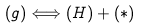Convert formula to latex. <formula><loc_0><loc_0><loc_500><loc_500>\left ( g \right ) \Longleftrightarrow \left ( H \right ) + \left ( \ast \right )</formula> 